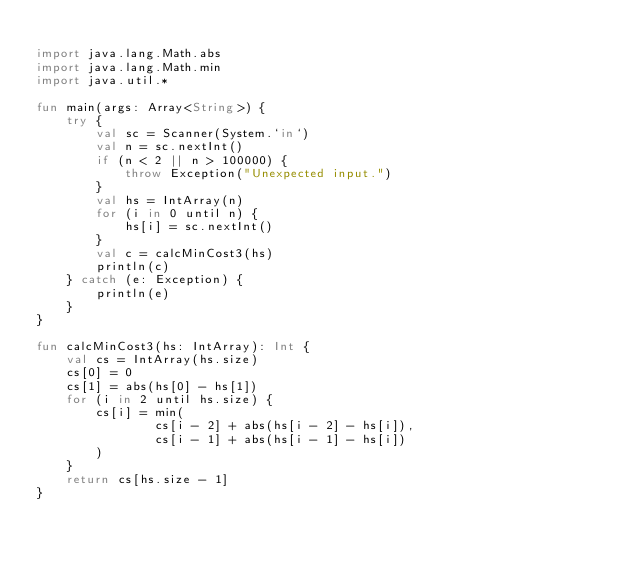Convert code to text. <code><loc_0><loc_0><loc_500><loc_500><_Kotlin_>
import java.lang.Math.abs
import java.lang.Math.min
import java.util.*

fun main(args: Array<String>) {
    try {
        val sc = Scanner(System.`in`)
        val n = sc.nextInt()
        if (n < 2 || n > 100000) {
            throw Exception("Unexpected input.")
        }
        val hs = IntArray(n)
        for (i in 0 until n) {
            hs[i] = sc.nextInt()
        }
        val c = calcMinCost3(hs)
        println(c)
    } catch (e: Exception) {
        println(e)
    }
}

fun calcMinCost3(hs: IntArray): Int {
    val cs = IntArray(hs.size)
    cs[0] = 0
    cs[1] = abs(hs[0] - hs[1])
    for (i in 2 until hs.size) {
        cs[i] = min(
                cs[i - 2] + abs(hs[i - 2] - hs[i]),
                cs[i - 1] + abs(hs[i - 1] - hs[i])
        )
    }
    return cs[hs.size - 1]
}
</code> 